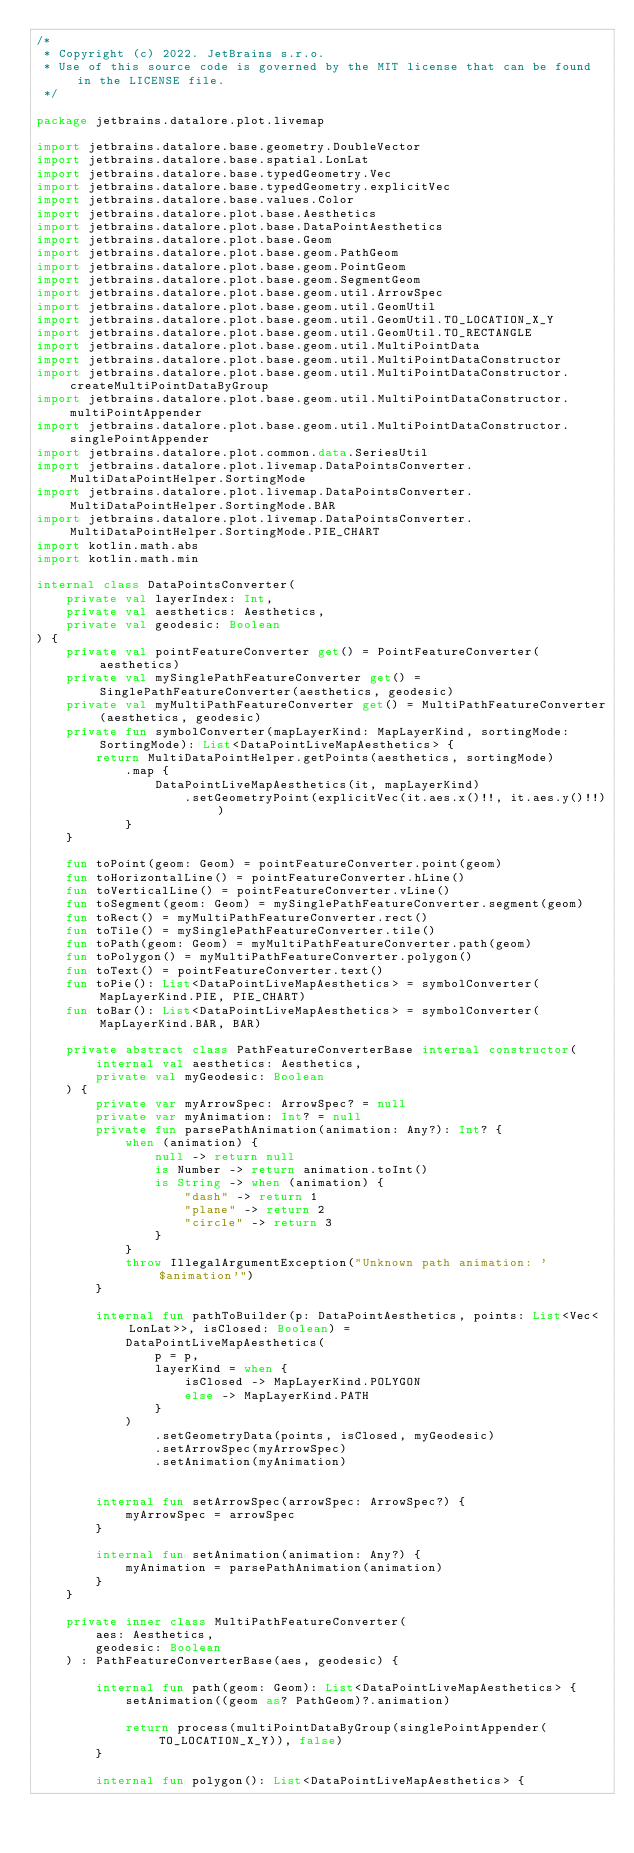Convert code to text. <code><loc_0><loc_0><loc_500><loc_500><_Kotlin_>/*
 * Copyright (c) 2022. JetBrains s.r.o.
 * Use of this source code is governed by the MIT license that can be found in the LICENSE file.
 */

package jetbrains.datalore.plot.livemap

import jetbrains.datalore.base.geometry.DoubleVector
import jetbrains.datalore.base.spatial.LonLat
import jetbrains.datalore.base.typedGeometry.Vec
import jetbrains.datalore.base.typedGeometry.explicitVec
import jetbrains.datalore.base.values.Color
import jetbrains.datalore.plot.base.Aesthetics
import jetbrains.datalore.plot.base.DataPointAesthetics
import jetbrains.datalore.plot.base.Geom
import jetbrains.datalore.plot.base.geom.PathGeom
import jetbrains.datalore.plot.base.geom.PointGeom
import jetbrains.datalore.plot.base.geom.SegmentGeom
import jetbrains.datalore.plot.base.geom.util.ArrowSpec
import jetbrains.datalore.plot.base.geom.util.GeomUtil
import jetbrains.datalore.plot.base.geom.util.GeomUtil.TO_LOCATION_X_Y
import jetbrains.datalore.plot.base.geom.util.GeomUtil.TO_RECTANGLE
import jetbrains.datalore.plot.base.geom.util.MultiPointData
import jetbrains.datalore.plot.base.geom.util.MultiPointDataConstructor
import jetbrains.datalore.plot.base.geom.util.MultiPointDataConstructor.createMultiPointDataByGroup
import jetbrains.datalore.plot.base.geom.util.MultiPointDataConstructor.multiPointAppender
import jetbrains.datalore.plot.base.geom.util.MultiPointDataConstructor.singlePointAppender
import jetbrains.datalore.plot.common.data.SeriesUtil
import jetbrains.datalore.plot.livemap.DataPointsConverter.MultiDataPointHelper.SortingMode
import jetbrains.datalore.plot.livemap.DataPointsConverter.MultiDataPointHelper.SortingMode.BAR
import jetbrains.datalore.plot.livemap.DataPointsConverter.MultiDataPointHelper.SortingMode.PIE_CHART
import kotlin.math.abs
import kotlin.math.min

internal class DataPointsConverter(
    private val layerIndex: Int,
    private val aesthetics: Aesthetics,
    private val geodesic: Boolean
) {
    private val pointFeatureConverter get() = PointFeatureConverter(aesthetics)
    private val mySinglePathFeatureConverter get() = SinglePathFeatureConverter(aesthetics, geodesic)
    private val myMultiPathFeatureConverter get() = MultiPathFeatureConverter(aesthetics, geodesic)
    private fun symbolConverter(mapLayerKind: MapLayerKind, sortingMode: SortingMode): List<DataPointLiveMapAesthetics> {
        return MultiDataPointHelper.getPoints(aesthetics, sortingMode)
            .map {
                DataPointLiveMapAesthetics(it, mapLayerKind)
                    .setGeometryPoint(explicitVec(it.aes.x()!!, it.aes.y()!!))
            }
    }

    fun toPoint(geom: Geom) = pointFeatureConverter.point(geom)
    fun toHorizontalLine() = pointFeatureConverter.hLine()
    fun toVerticalLine() = pointFeatureConverter.vLine()
    fun toSegment(geom: Geom) = mySinglePathFeatureConverter.segment(geom)
    fun toRect() = myMultiPathFeatureConverter.rect()
    fun toTile() = mySinglePathFeatureConverter.tile()
    fun toPath(geom: Geom) = myMultiPathFeatureConverter.path(geom)
    fun toPolygon() = myMultiPathFeatureConverter.polygon()
    fun toText() = pointFeatureConverter.text()
    fun toPie(): List<DataPointLiveMapAesthetics> = symbolConverter(MapLayerKind.PIE, PIE_CHART)
    fun toBar(): List<DataPointLiveMapAesthetics> = symbolConverter(MapLayerKind.BAR, BAR)

    private abstract class PathFeatureConverterBase internal constructor(
        internal val aesthetics: Aesthetics,
        private val myGeodesic: Boolean
    ) {
        private var myArrowSpec: ArrowSpec? = null
        private var myAnimation: Int? = null
        private fun parsePathAnimation(animation: Any?): Int? {
            when (animation) {
                null -> return null
                is Number -> return animation.toInt()
                is String -> when (animation) {
                    "dash" -> return 1
                    "plane" -> return 2
                    "circle" -> return 3
                }
            }
            throw IllegalArgumentException("Unknown path animation: '$animation'")
        }

        internal fun pathToBuilder(p: DataPointAesthetics, points: List<Vec<LonLat>>, isClosed: Boolean) =
            DataPointLiveMapAesthetics(
                p = p,
                layerKind = when {
                    isClosed -> MapLayerKind.POLYGON
                    else -> MapLayerKind.PATH
                }
            )
                .setGeometryData(points, isClosed, myGeodesic)
                .setArrowSpec(myArrowSpec)
                .setAnimation(myAnimation)


        internal fun setArrowSpec(arrowSpec: ArrowSpec?) {
            myArrowSpec = arrowSpec
        }

        internal fun setAnimation(animation: Any?) {
            myAnimation = parsePathAnimation(animation)
        }
    }

    private inner class MultiPathFeatureConverter(
        aes: Aesthetics,
        geodesic: Boolean
    ) : PathFeatureConverterBase(aes, geodesic) {

        internal fun path(geom: Geom): List<DataPointLiveMapAesthetics> {
            setAnimation((geom as? PathGeom)?.animation)

            return process(multiPointDataByGroup(singlePointAppender(TO_LOCATION_X_Y)), false)
        }

        internal fun polygon(): List<DataPointLiveMapAesthetics> {</code> 